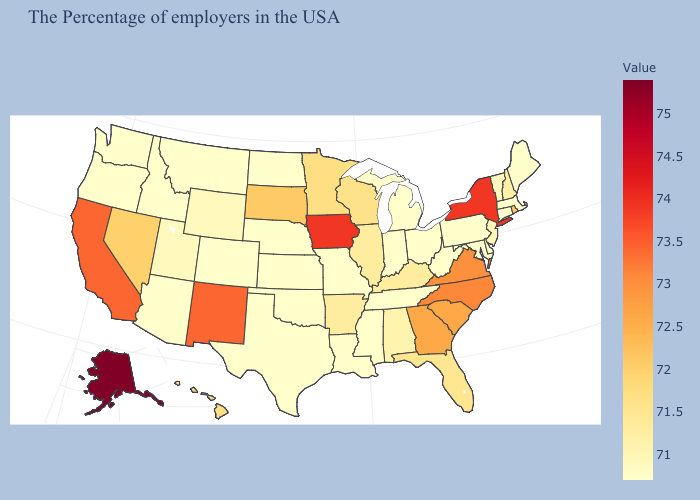Does Alabama have the lowest value in the USA?
Keep it brief. No. Among the states that border Georgia , which have the highest value?
Keep it brief. North Carolina. Does New Hampshire have a lower value than Nevada?
Be succinct. Yes. Does New York have the highest value in the Northeast?
Be succinct. Yes. Among the states that border New Jersey , does Pennsylvania have the lowest value?
Quick response, please. Yes. 